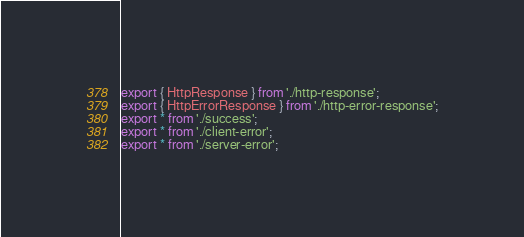<code> <loc_0><loc_0><loc_500><loc_500><_TypeScript_>export { HttpResponse } from './http-response';
export { HttpErrorResponse } from './http-error-response';
export * from './success';
export * from './client-error';
export * from './server-error';
</code> 